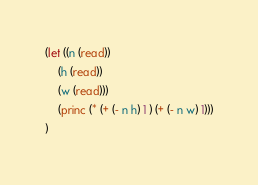<code> <loc_0><loc_0><loc_500><loc_500><_Lisp_>(let ((n (read))
    (h (read))
    (w (read)))
    (princ (* (+ (- n h) 1 ) (+ (- n w) 1)))
)</code> 